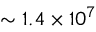<formula> <loc_0><loc_0><loc_500><loc_500>\sim 1 . 4 \times 1 0 ^ { 7 }</formula> 